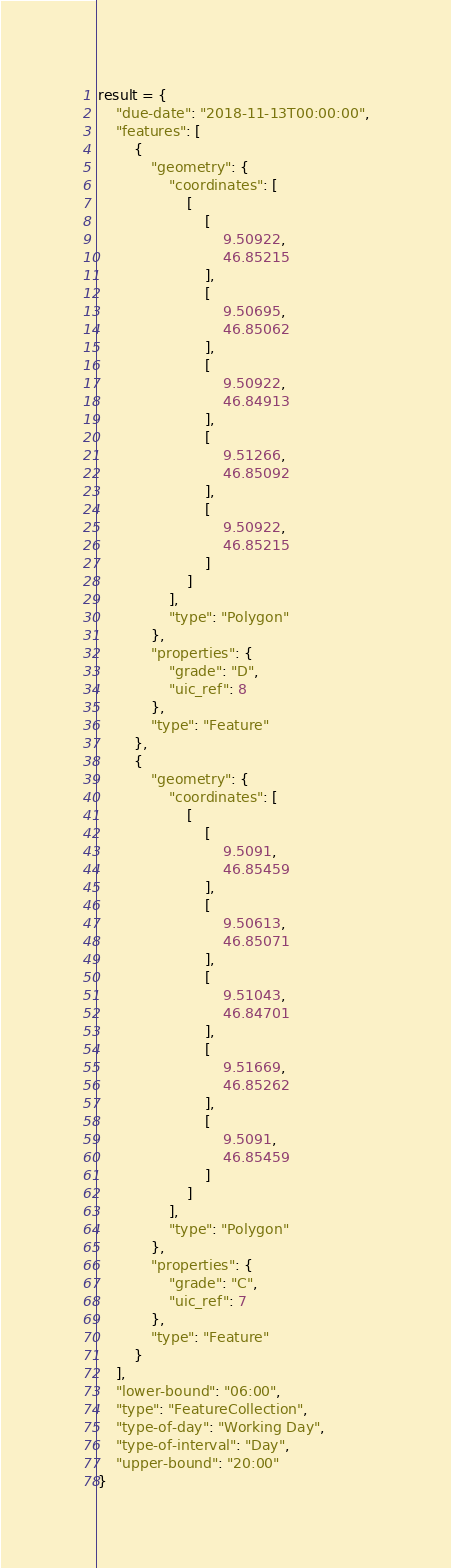Convert code to text. <code><loc_0><loc_0><loc_500><loc_500><_Python_>result = {
    "due-date": "2018-11-13T00:00:00",
    "features": [
        {
            "geometry": {
                "coordinates": [
                    [
                        [
                            9.50922,
                            46.85215
                        ],
                        [
                            9.50695,
                            46.85062
                        ],
                        [
                            9.50922,
                            46.84913
                        ],
                        [
                            9.51266,
                            46.85092
                        ],
                        [
                            9.50922,
                            46.85215
                        ]
                    ]
                ],
                "type": "Polygon"
            },
            "properties": {
                "grade": "D",
                "uic_ref": 8
            },
            "type": "Feature"
        },
        {
            "geometry": {
                "coordinates": [
                    [
                        [
                            9.5091,
                            46.85459
                        ],
                        [
                            9.50613,
                            46.85071
                        ],
                        [
                            9.51043,
                            46.84701
                        ],
                        [
                            9.51669,
                            46.85262
                        ],
                        [
                            9.5091,
                            46.85459
                        ]
                    ]
                ],
                "type": "Polygon"
            },
            "properties": {
                "grade": "C",
                "uic_ref": 7
            },
            "type": "Feature"
        }
    ],
    "lower-bound": "06:00",
    "type": "FeatureCollection",
    "type-of-day": "Working Day",
    "type-of-interval": "Day",
    "upper-bound": "20:00"
}
</code> 